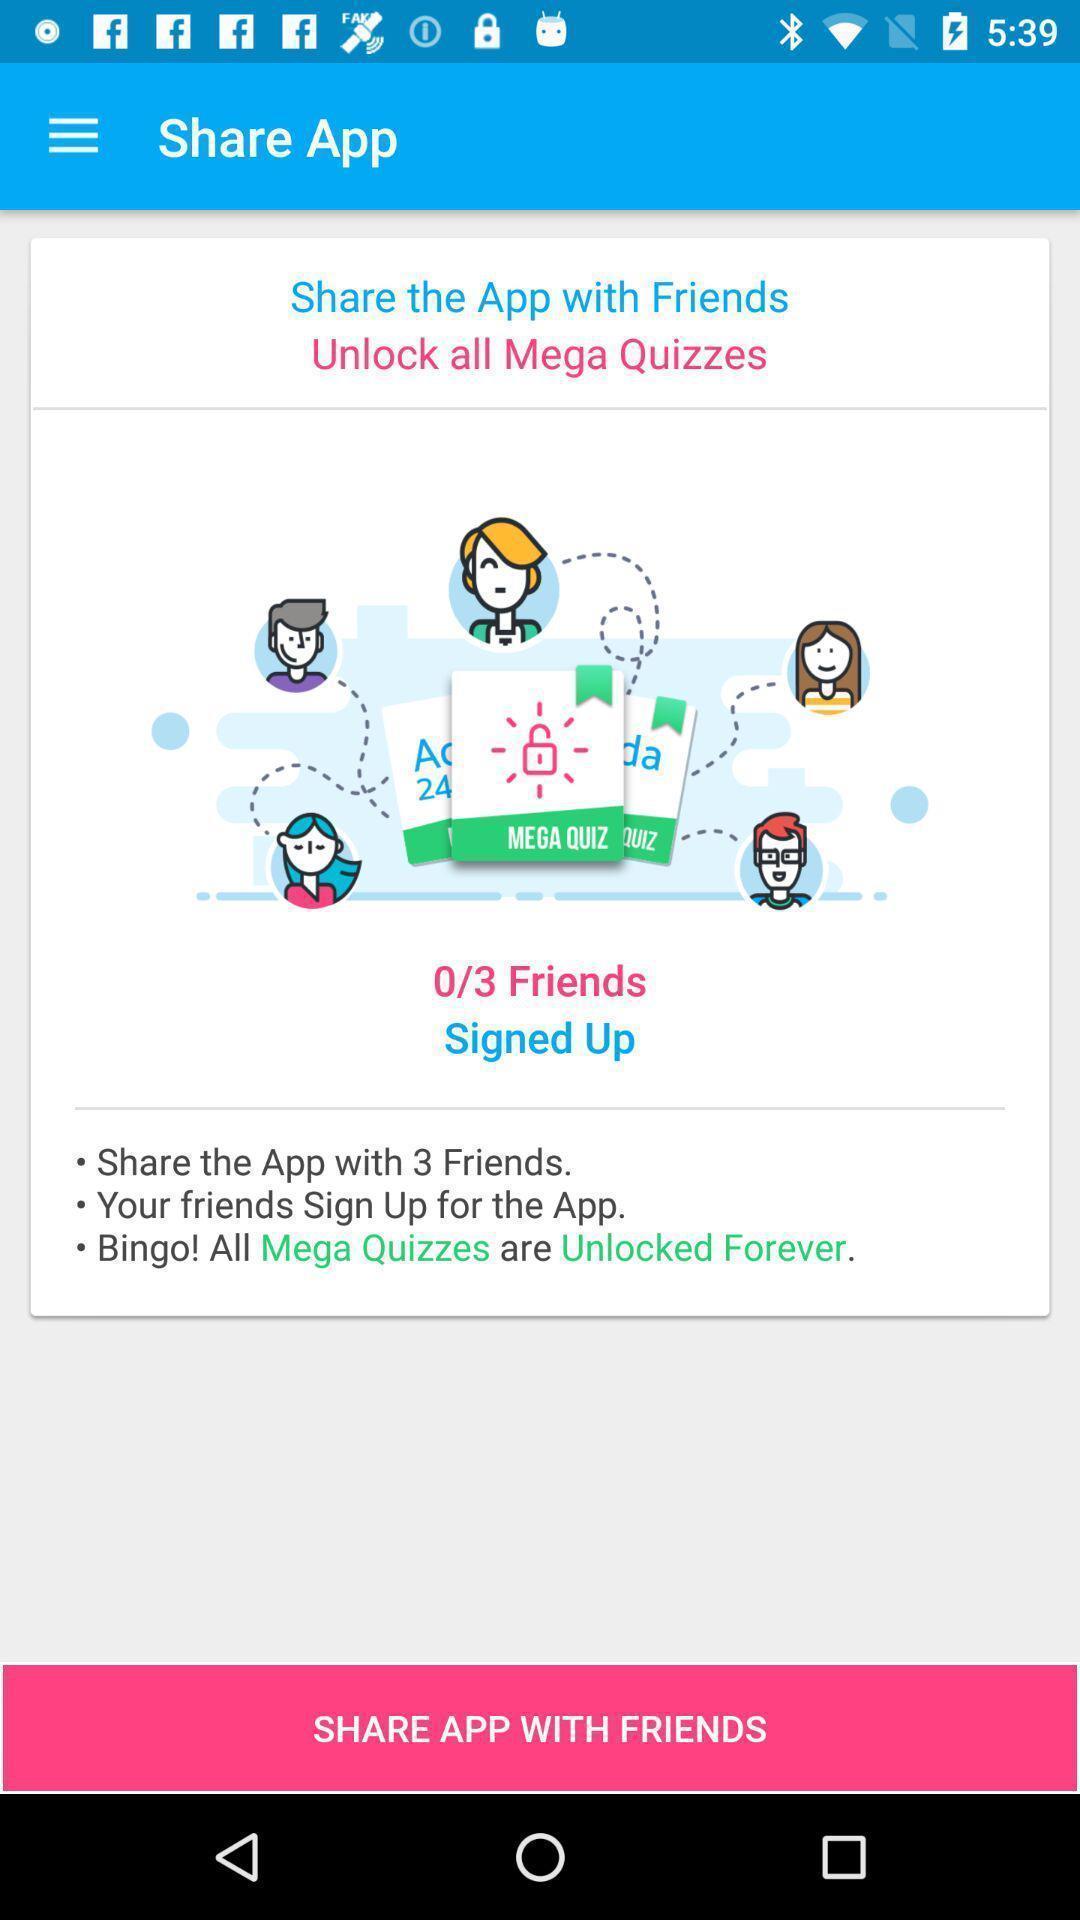Tell me about the visual elements in this screen capture. Page shows to send quiz app with friends. 